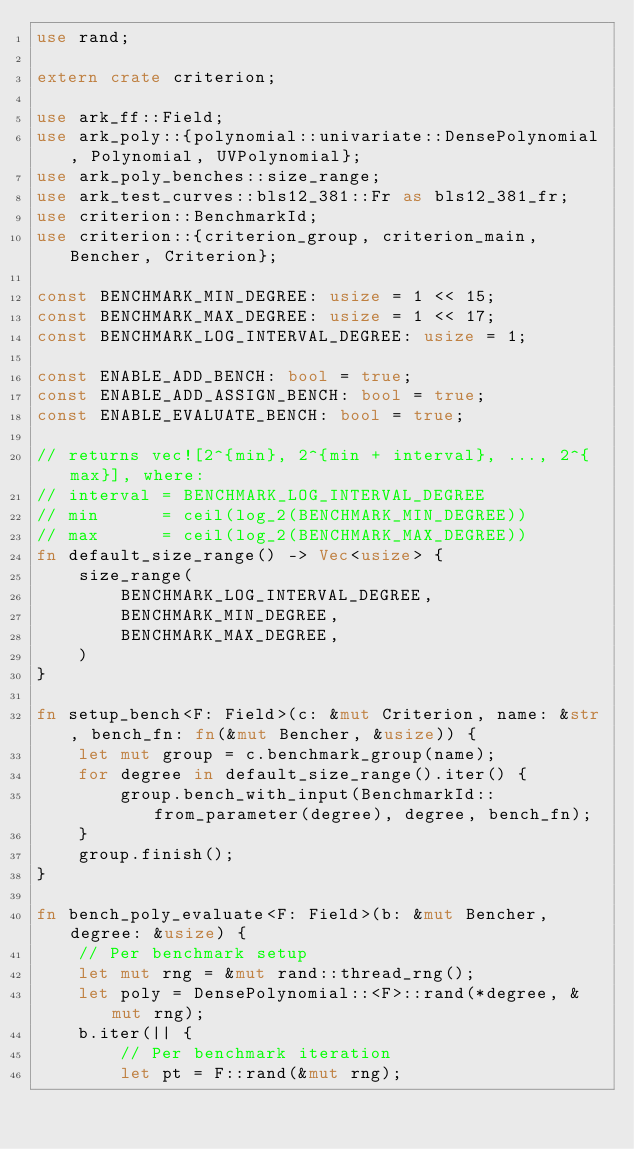<code> <loc_0><loc_0><loc_500><loc_500><_Rust_>use rand;

extern crate criterion;

use ark_ff::Field;
use ark_poly::{polynomial::univariate::DensePolynomial, Polynomial, UVPolynomial};
use ark_poly_benches::size_range;
use ark_test_curves::bls12_381::Fr as bls12_381_fr;
use criterion::BenchmarkId;
use criterion::{criterion_group, criterion_main, Bencher, Criterion};

const BENCHMARK_MIN_DEGREE: usize = 1 << 15;
const BENCHMARK_MAX_DEGREE: usize = 1 << 17;
const BENCHMARK_LOG_INTERVAL_DEGREE: usize = 1;

const ENABLE_ADD_BENCH: bool = true;
const ENABLE_ADD_ASSIGN_BENCH: bool = true;
const ENABLE_EVALUATE_BENCH: bool = true;

// returns vec![2^{min}, 2^{min + interval}, ..., 2^{max}], where:
// interval = BENCHMARK_LOG_INTERVAL_DEGREE
// min      = ceil(log_2(BENCHMARK_MIN_DEGREE))
// max      = ceil(log_2(BENCHMARK_MAX_DEGREE))
fn default_size_range() -> Vec<usize> {
    size_range(
        BENCHMARK_LOG_INTERVAL_DEGREE,
        BENCHMARK_MIN_DEGREE,
        BENCHMARK_MAX_DEGREE,
    )
}

fn setup_bench<F: Field>(c: &mut Criterion, name: &str, bench_fn: fn(&mut Bencher, &usize)) {
    let mut group = c.benchmark_group(name);
    for degree in default_size_range().iter() {
        group.bench_with_input(BenchmarkId::from_parameter(degree), degree, bench_fn);
    }
    group.finish();
}

fn bench_poly_evaluate<F: Field>(b: &mut Bencher, degree: &usize) {
    // Per benchmark setup
    let mut rng = &mut rand::thread_rng();
    let poly = DensePolynomial::<F>::rand(*degree, &mut rng);
    b.iter(|| {
        // Per benchmark iteration
        let pt = F::rand(&mut rng);</code> 